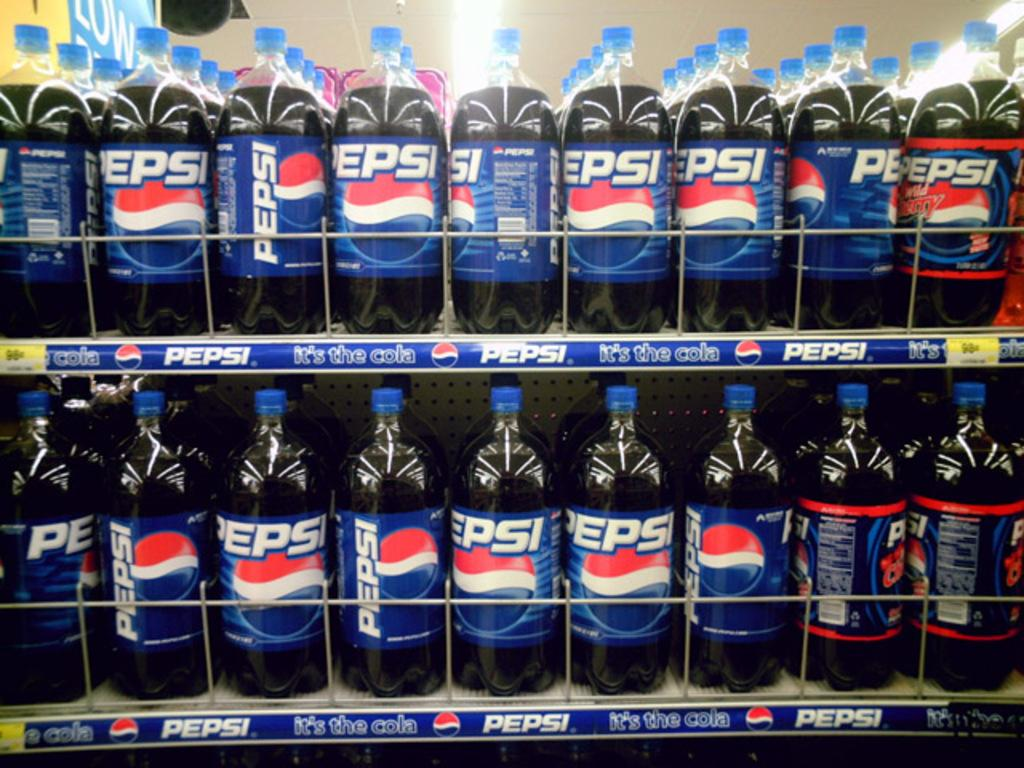<image>
Give a short and clear explanation of the subsequent image. two shelves of pepsi bottles inside of a store 